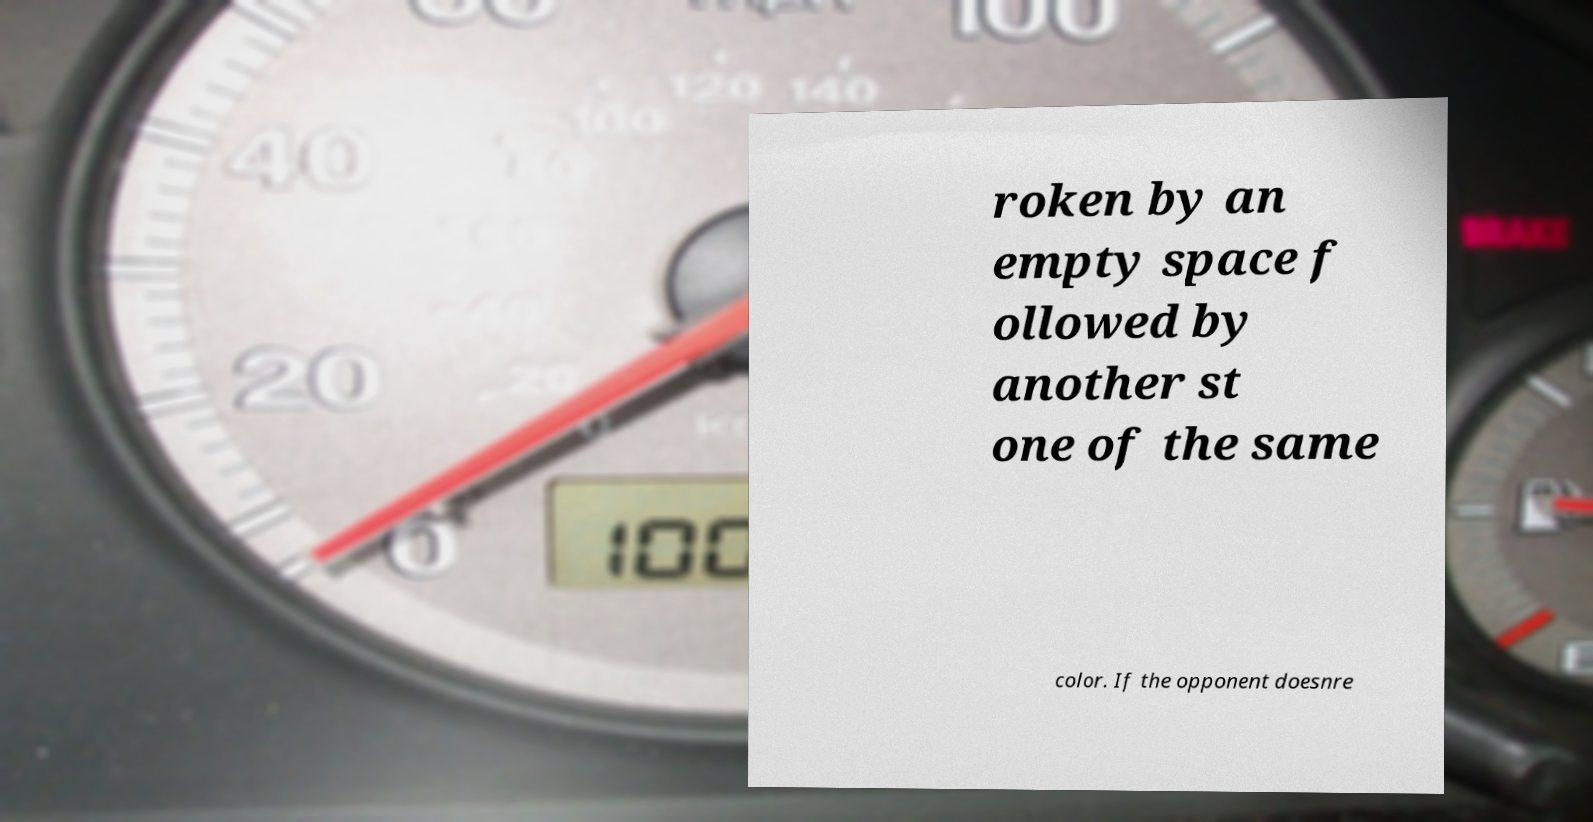Could you extract and type out the text from this image? roken by an empty space f ollowed by another st one of the same color. If the opponent doesnre 